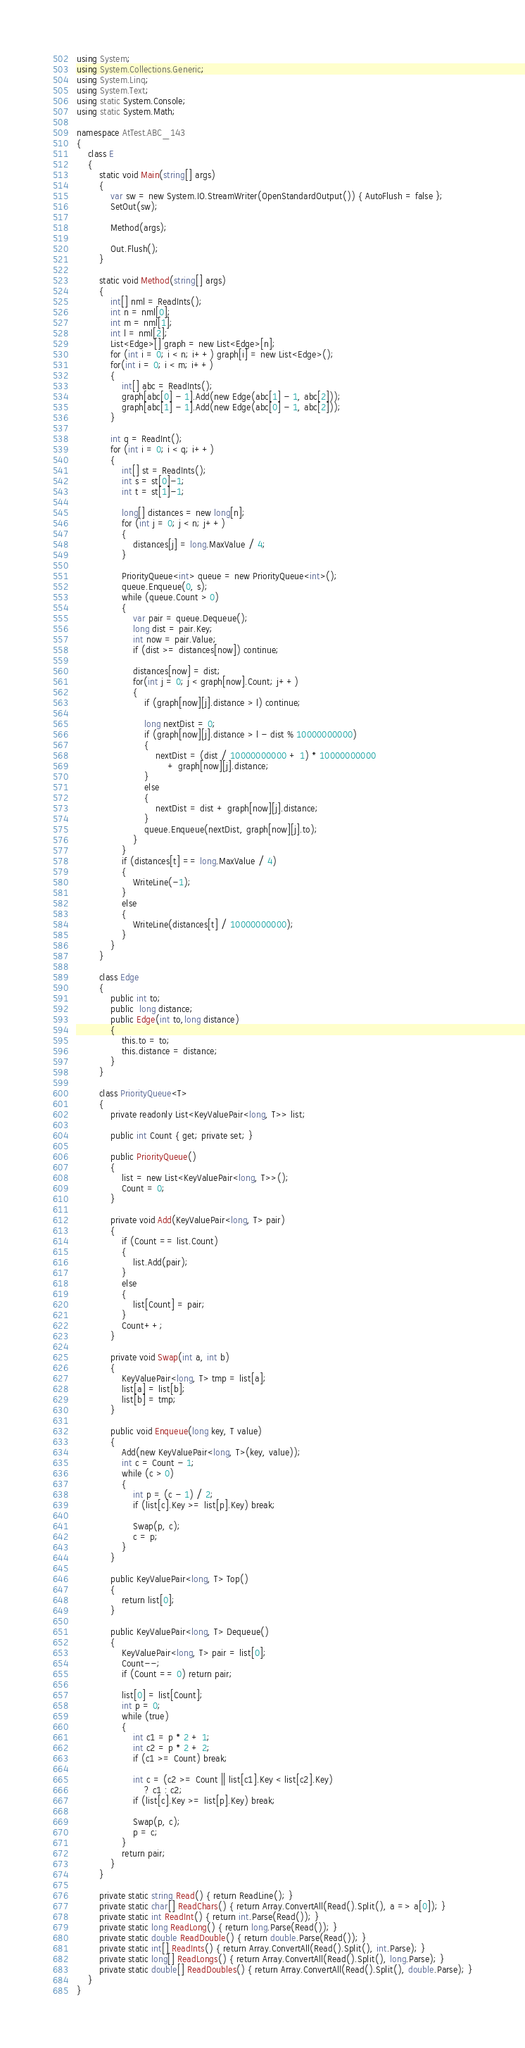Convert code to text. <code><loc_0><loc_0><loc_500><loc_500><_C#_>using System;
using System.Collections.Generic;
using System.Linq;
using System.Text;
using static System.Console;
using static System.Math;

namespace AtTest.ABC_143
{
    class E
    {
        static void Main(string[] args)
        {
            var sw = new System.IO.StreamWriter(OpenStandardOutput()) { AutoFlush = false };
            SetOut(sw);

            Method(args);

            Out.Flush();
        }

        static void Method(string[] args)
        {
            int[] nml = ReadInts();
            int n = nml[0];
            int m = nml[1];
            int l = nml[2];
            List<Edge>[] graph = new List<Edge>[n];
            for (int i = 0; i < n; i++) graph[i] = new List<Edge>();
            for(int i = 0; i < m; i++)
            {
                int[] abc = ReadInts();
                graph[abc[0] - 1].Add(new Edge(abc[1] - 1, abc[2]));
                graph[abc[1] - 1].Add(new Edge(abc[0] - 1, abc[2]));
            }

            int q = ReadInt();
            for (int i = 0; i < q; i++)
            {
                int[] st = ReadInts();
                int s = st[0]-1;
                int t = st[1]-1;

                long[] distances = new long[n];
                for (int j = 0; j < n; j++)
                {
                    distances[j] = long.MaxValue / 4;
                }

                PriorityQueue<int> queue = new PriorityQueue<int>();
                queue.Enqueue(0, s);
                while (queue.Count > 0)
                {
                    var pair = queue.Dequeue();
                    long dist = pair.Key;
                    int now = pair.Value;
                    if (dist >= distances[now]) continue;

                    distances[now] = dist;
                    for(int j = 0; j < graph[now].Count; j++)
                    {
                        if (graph[now][j].distance > l) continue;

                        long nextDist = 0;
                        if (graph[now][j].distance > l - dist % 10000000000)
                        {
                            nextDist = (dist / 10000000000 + 1) * 10000000000
                                + graph[now][j].distance;
                        }
                        else
                        {
                            nextDist = dist + graph[now][j].distance;
                        }
                        queue.Enqueue(nextDist, graph[now][j].to);
                    }
                }
                if (distances[t] == long.MaxValue / 4)
                {
                    WriteLine(-1);
                }
                else
                {
                    WriteLine(distances[t] / 10000000000);
                }
            }
        }

        class Edge
        {
            public int to;
            public  long distance;
            public Edge(int to,long distance)
            {
                this.to = to;
                this.distance = distance;
            }
        }

        class PriorityQueue<T>
        {
            private readonly List<KeyValuePair<long, T>> list;

            public int Count { get; private set; }

            public PriorityQueue()
            {
                list = new List<KeyValuePair<long, T>>();
                Count = 0;
            }

            private void Add(KeyValuePair<long, T> pair)
            {
                if (Count == list.Count)
                {
                    list.Add(pair);
                }
                else
                {
                    list[Count] = pair;
                }
                Count++;
            }

            private void Swap(int a, int b)
            {
                KeyValuePair<long, T> tmp = list[a];
                list[a] = list[b];
                list[b] = tmp;
            }

            public void Enqueue(long key, T value)
            {
                Add(new KeyValuePair<long, T>(key, value));
                int c = Count - 1;
                while (c > 0)
                {
                    int p = (c - 1) / 2;
                    if (list[c].Key >= list[p].Key) break;

                    Swap(p, c);
                    c = p;
                }
            }

            public KeyValuePair<long, T> Top()
            {
                return list[0];
            }

            public KeyValuePair<long, T> Dequeue()
            {
                KeyValuePair<long, T> pair = list[0];
                Count--;
                if (Count == 0) return pair;

                list[0] = list[Count];
                int p = 0;
                while (true)
                {
                    int c1 = p * 2 + 1;
                    int c2 = p * 2 + 2;
                    if (c1 >= Count) break;

                    int c = (c2 >= Count || list[c1].Key < list[c2].Key)
                        ? c1 : c2;
                    if (list[c].Key >= list[p].Key) break;

                    Swap(p, c);
                    p = c;
                }
                return pair;
            }
        }

        private static string Read() { return ReadLine(); }
        private static char[] ReadChars() { return Array.ConvertAll(Read().Split(), a => a[0]); }
        private static int ReadInt() { return int.Parse(Read()); }
        private static long ReadLong() { return long.Parse(Read()); }
        private static double ReadDouble() { return double.Parse(Read()); }
        private static int[] ReadInts() { return Array.ConvertAll(Read().Split(), int.Parse); }
        private static long[] ReadLongs() { return Array.ConvertAll(Read().Split(), long.Parse); }
        private static double[] ReadDoubles() { return Array.ConvertAll(Read().Split(), double.Parse); }
    }
}
</code> 